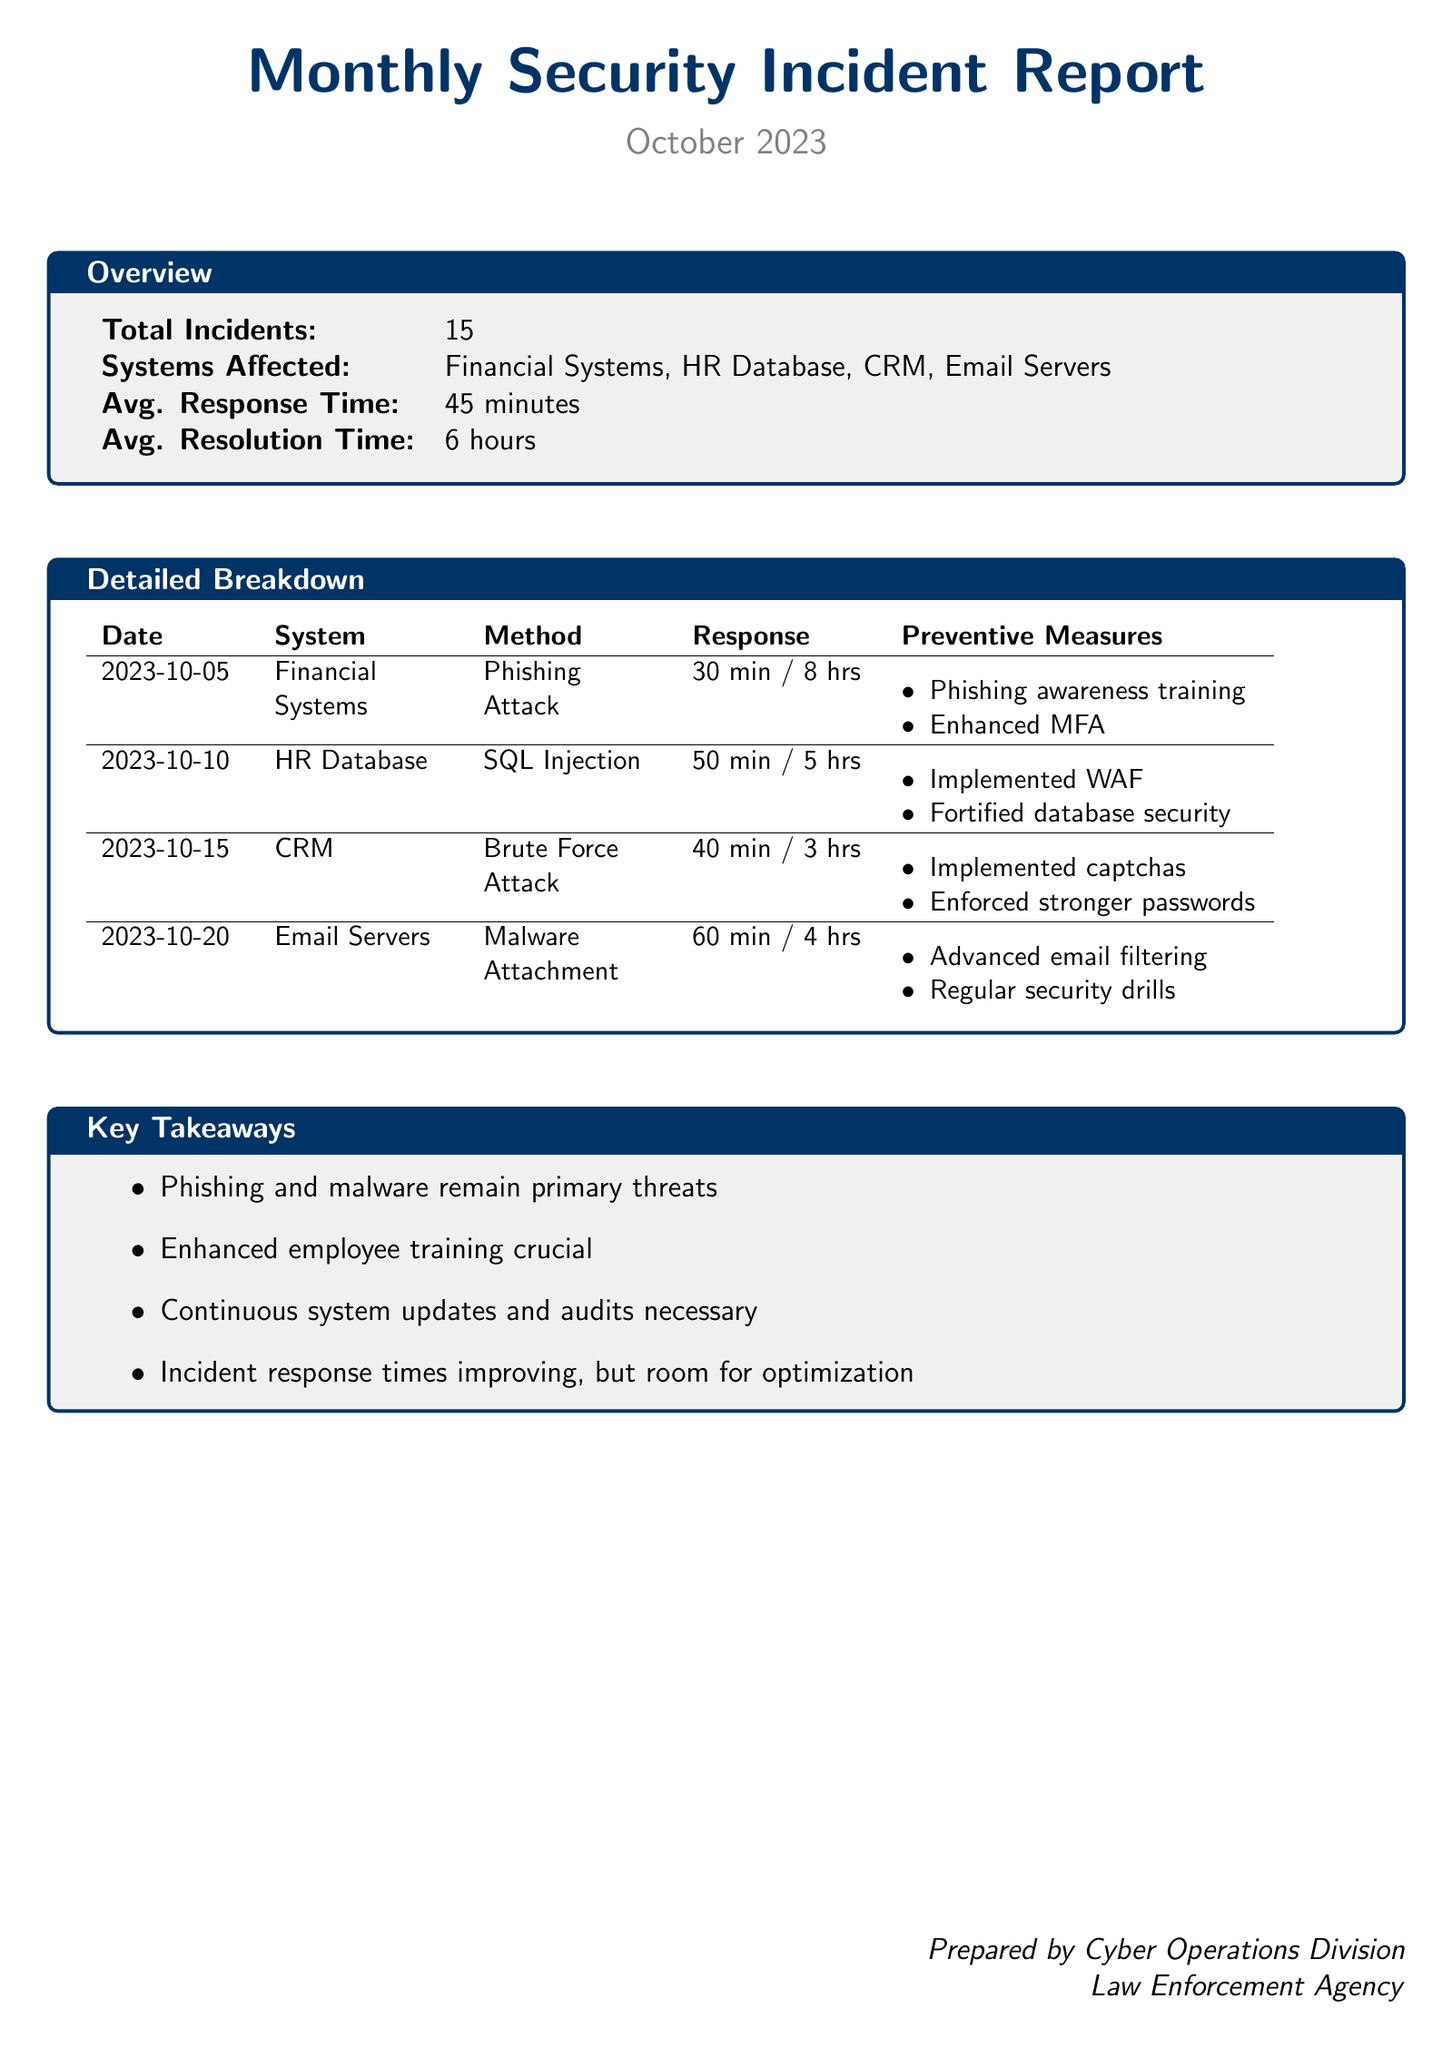What is the total number of incidents reported? The total number of incidents is mentioned in the Overview section of the document.
Answer: 15 What was the average response time for incidents? The average response time is provided in the Overview section.
Answer: 45 minutes Which system was affected by the SQL Injection? The affected system by the SQL Injection is listed in the Detailed Breakdown.
Answer: HR Database What method was used in the phishing attack? The method used in the phishing attack is detailed in the Breakdown column of the report.
Answer: Phishing Attack What preventive measure was taken after the malware attachment incident? The preventive measures are listed next to the incident details for the Email Servers in the Detailed Breakdown.
Answer: Advanced email filtering Which incident had the longest response time? The response times for each incident are given, allowing comparison for identifying the longest one.
Answer: Email Servers How many systems were affected in total? The total number of systems affected is summarized in the Overview section of the document.
Answer: 4 What was the average resolution time for incidents? The average resolution time is provided in the Overview section of the report.
Answer: 6 hours What category of threats remains primary according to the key takeaways? The key takeaways summarize the main threats highlighted in the report.
Answer: Phishing and malware 